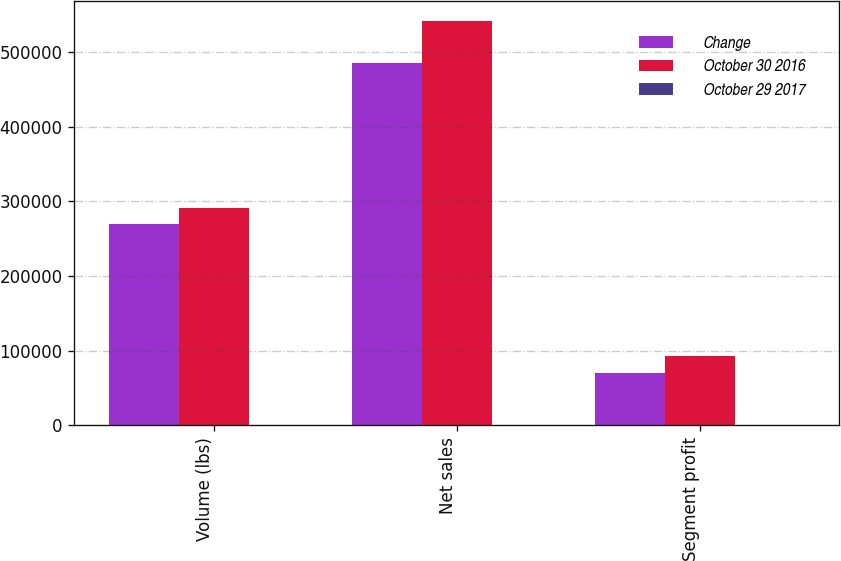<chart> <loc_0><loc_0><loc_500><loc_500><stacked_bar_chart><ecel><fcel>Volume (lbs)<fcel>Net sales<fcel>Segment profit<nl><fcel>Change<fcel>270175<fcel>484856<fcel>70370<nl><fcel>October 30 2016<fcel>291587<fcel>541409<fcel>92299<nl><fcel>October 29 2017<fcel>7.3<fcel>10.4<fcel>23.8<nl></chart> 